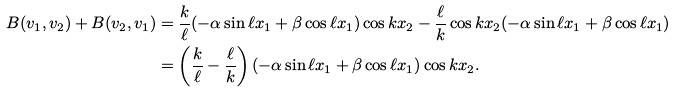Convert formula to latex. <formula><loc_0><loc_0><loc_500><loc_500>B ( v _ { 1 } , v _ { 2 } ) + B ( v _ { 2 } , v _ { 1 } ) & = \frac { k } { \ell } ( - \alpha \sin \ell x _ { 1 } + \beta \cos \ell x _ { 1 } ) \cos k x _ { 2 } - \frac { \ell } { k } \cos k x _ { 2 } ( - \alpha \sin \ell x _ { 1 } + \beta \cos \ell x _ { 1 } ) \\ & = \left ( \frac { k } { \ell } - \frac { \ell } { k } \right ) ( - \alpha \sin \ell x _ { 1 } + \beta \cos \ell x _ { 1 } ) \cos k x _ { 2 } .</formula> 